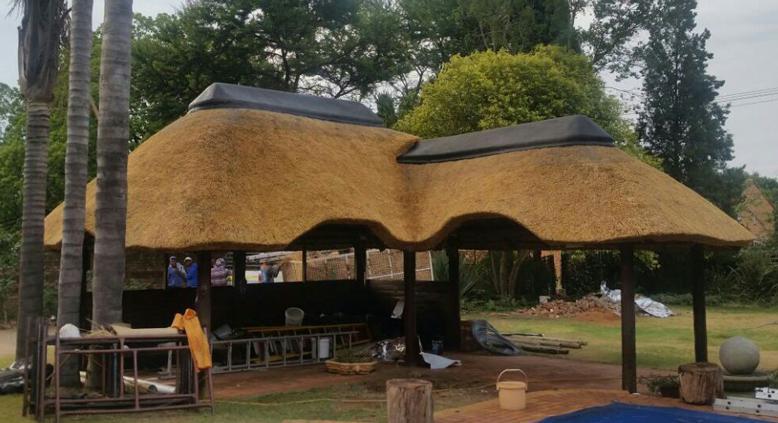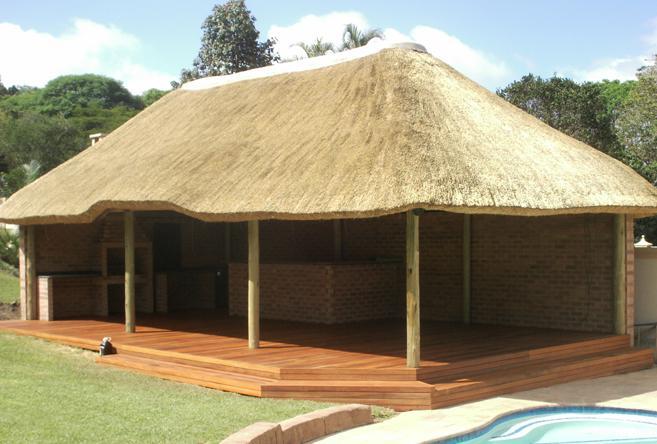The first image is the image on the left, the second image is the image on the right. Given the left and right images, does the statement "The right image shows a roof made of plant material draped over leafless tree supports with forked limbs." hold true? Answer yes or no. No. The first image is the image on the left, the second image is the image on the right. Evaluate the accuracy of this statement regarding the images: "The vertical posts are real tree trunks.". Is it true? Answer yes or no. No. 